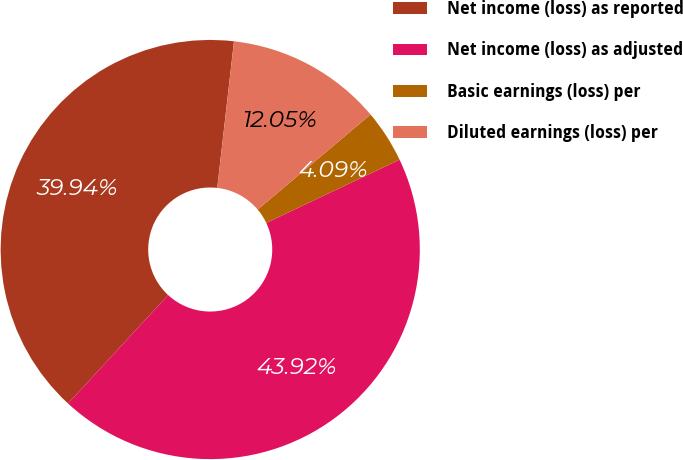Convert chart. <chart><loc_0><loc_0><loc_500><loc_500><pie_chart><fcel>Net income (loss) as reported<fcel>Net income (loss) as adjusted<fcel>Basic earnings (loss) per<fcel>Diluted earnings (loss) per<nl><fcel>39.94%<fcel>43.92%<fcel>4.09%<fcel>12.05%<nl></chart> 